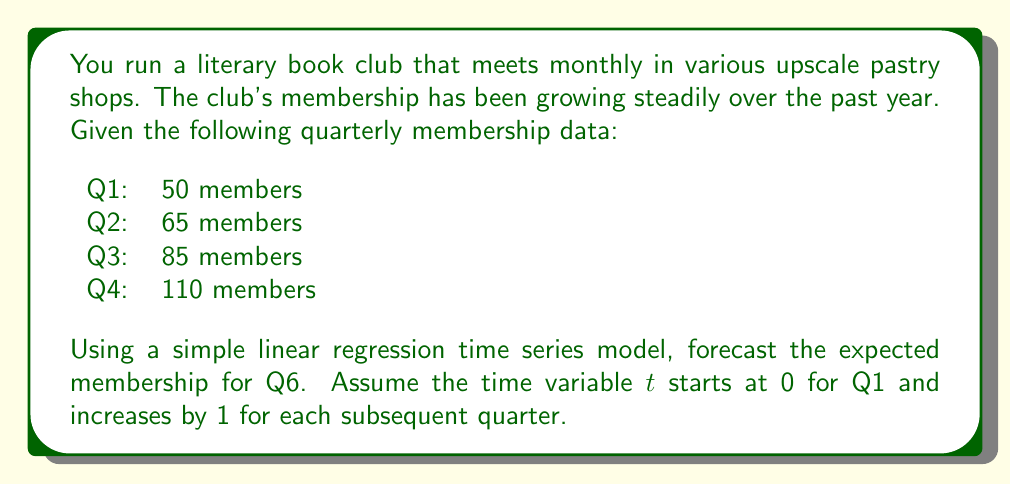Show me your answer to this math problem. To forecast the membership for Q6 using a simple linear regression time series model, we'll follow these steps:

1) First, let's set up our data:
   t (time): 0, 1, 2, 3
   y (membership): 50, 65, 85, 110

2) We'll use the linear regression equation: $y = \beta_0 + \beta_1t + \epsilon$

   Where $\beta_0$ is the y-intercept, $\beta_1$ is the slope, and $\epsilon$ is the error term.

3) To find $\beta_0$ and $\beta_1$, we'll use these formulas:

   $\beta_1 = \frac{n\sum{ty} - \sum{t}\sum{y}}{n\sum{t^2} - (\sum{t})^2}$

   $\beta_0 = \bar{y} - \beta_1\bar{t}$

4) Let's calculate the necessary sums:
   $n = 4$
   $\sum{t} = 0 + 1 + 2 + 3 = 6$
   $\sum{y} = 50 + 65 + 85 + 110 = 310$
   $\sum{ty} = 0(50) + 1(65) + 2(85) + 3(110) = 565$
   $\sum{t^2} = 0^2 + 1^2 + 2^2 + 3^2 = 14$

5) Now we can calculate $\beta_1$:
   
   $\beta_1 = \frac{4(565) - 6(310)}{4(14) - 6^2} = \frac{2260 - 1860}{56 - 36} = \frac{400}{20} = 20$

6) To find $\beta_0$, we need $\bar{y}$ and $\bar{t}$:
   
   $\bar{y} = \frac{310}{4} = 77.5$
   $\bar{t} = \frac{6}{4} = 1.5$

   $\beta_0 = 77.5 - 20(1.5) = 77.5 - 30 = 47.5$

7) Our regression equation is therefore:

   $y = 47.5 + 20t$

8) To forecast Q6, we use t = 5 (as Q6 is 5 quarters after Q1):

   $y = 47.5 + 20(5) = 47.5 + 100 = 147.5$

Therefore, the forecasted membership for Q6 is 147.5, which we round to 148 members.
Answer: 148 members 